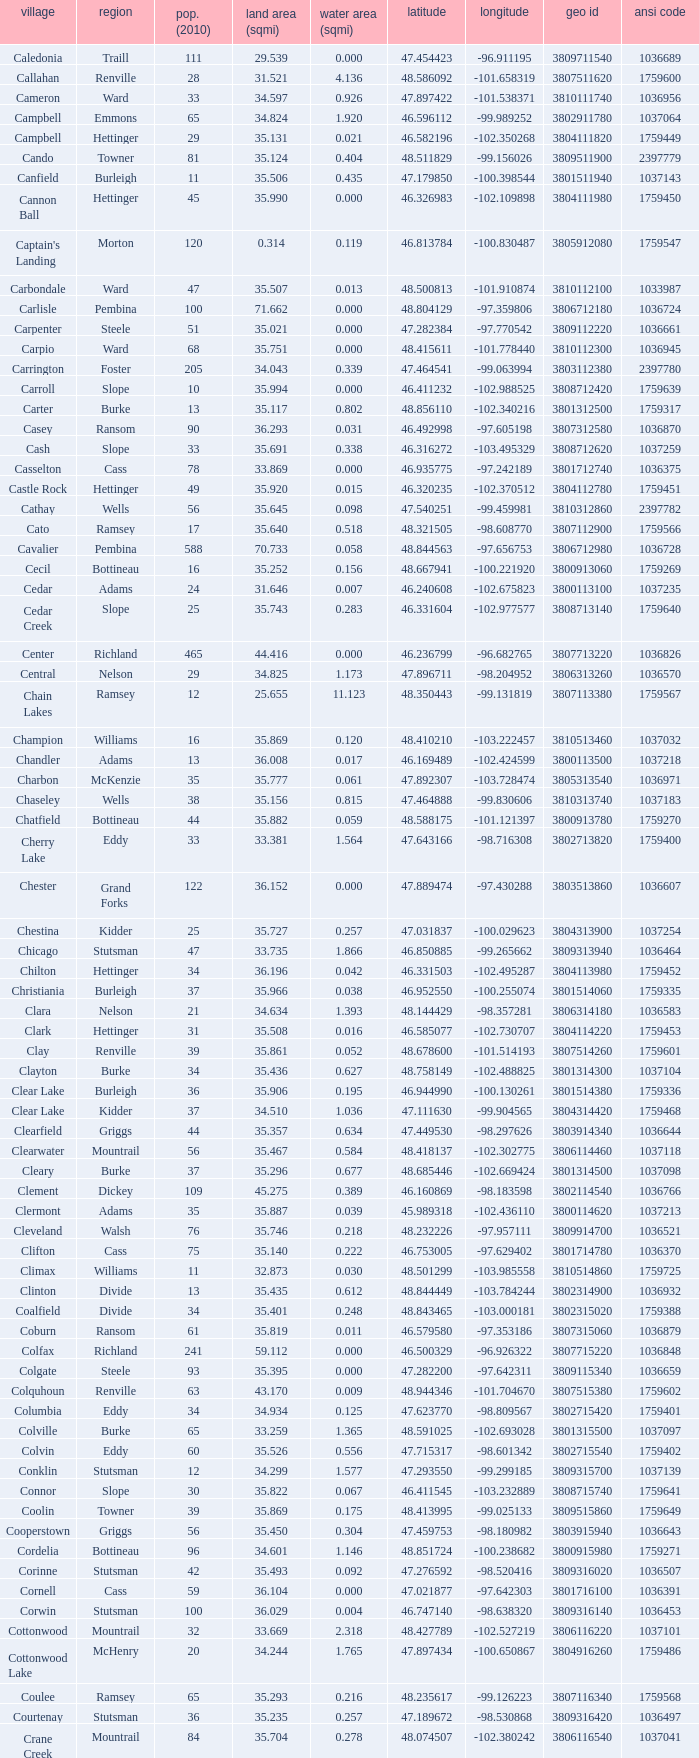What was the longitude of the township with a latitude of 48.075823? -98.857272. 